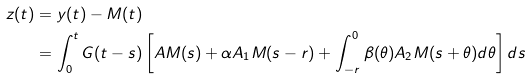<formula> <loc_0><loc_0><loc_500><loc_500>z ( t ) & = y ( t ) - M ( t ) \\ & = \int ^ { t } _ { 0 } G ( t - s ) \left [ A M ( s ) + \alpha A _ { 1 } M ( s - r ) + \int ^ { 0 } _ { - r } \beta ( \theta ) A _ { 2 } M ( s + \theta ) d \theta \right ] d s</formula> 